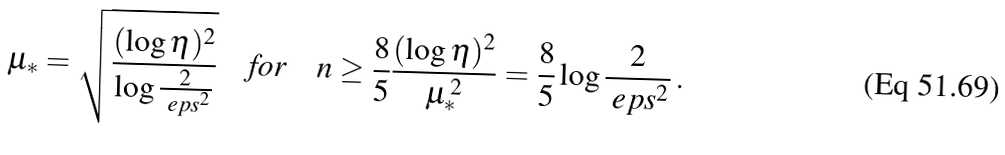Convert formula to latex. <formula><loc_0><loc_0><loc_500><loc_500>\mu _ { * } = \sqrt { \frac { ( \log \eta ) ^ { 2 } } { \log \frac { 2 } { \ e p s ^ { 2 } } } } \quad \text {for} \quad n \geq \frac { 8 } { 5 } \frac { ( \log \eta ) ^ { 2 } } { \mu _ { * } ^ { \, 2 } } = \frac { 8 } { 5 } \log \frac { 2 } { \ e p s ^ { 2 } } \, .</formula> 